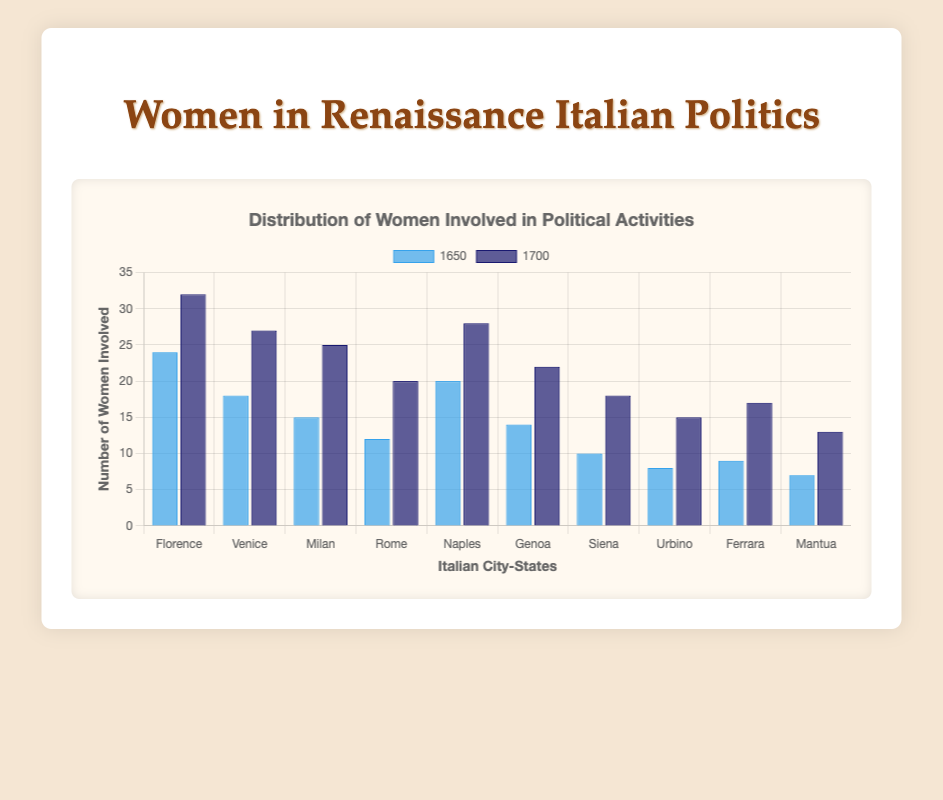Which city-state had the most significant increase in the number of women involved in political activities from 1650 to 1700? The increase in each city-state is calculated by subtracting the number of women involved in 1650 from the number involved in 1700. Florence had an increase of 8 (32 - 24), Venice had an increase of 9 (27 - 18), Milan had an increase of 10 (25 - 15), Rome had an increase of 8 (20 - 12), Naples had an increase of 8 (28 - 20), Genoa had an increase of 8 (22 - 14), Siena had an increase of 8 (18 - 10), Urbino had an increase of 7 (15 - 8), Ferrara had an increase of 8 (17 - 9), and Mantua had an increase of 6 (13 - 7). As a result, Milan had the most significant increase.
Answer: Milan Which city-state had the lowest number of women involved in political activities in 1650? Looking at the bar representing 1650, the lowest bar corresponds to Mantua, which had 7 women involved.
Answer: Mantua How many total women were involved in political activities across all city-states in 1700? Add the number of women involved in each city-state in 1700: 32 (Florence) + 27 (Venice) + 25 (Milan) + 20 (Rome) + 28 (Naples) + 22 (Genoa) + 18 (Siena) + 15 (Urbino) + 17 (Ferrara) + 13 (Mantua). The total is 217.
Answer: 217 Which city-state showed the smallest relative growth in the number of women involved from 1650 to 1700? Calculate the relative growth by dividing the increase by the number of women involved in 1650. Florence's growth is 8/24, Venice's is 9/18, Milan's is 10/15, Rome's is 8/12, Naples' is 8/20, Genoa's is 8/14, Siena's is 8/10, Urbino’s is 7/8, Ferrara's is 8/9, and Mantua's is 6/7. Urbino has the smallest relative growth.
Answer: Urbino Which city-states had equal numbers of women involved in political activities in both 1650 and 1700? By comparing the bars, no city-states have equal numbers of women involved in both 1650 and 1700.
Answer: None What is the average number of women involved in political activities across all city-states in 1650? Add the number of women involved in each city-state in 1650 and divide by the number of city-states: (24 + 18 + 15 + 12 + 20 + 14 + 10 + 8 + 9 + 7) / 10. This equals 137 / 10, so the average is 13.7.
Answer: 13.7 Which city-state had the highest number of women involved in political activities in 1700? Comparing the heights of the bars for the year 1700, Florence had the highest number with 32 women involved.
Answer: Florence What is the total increase in the number of women involved in political activities from 1650 to 1700 across all city-states? Calculate the increase for each city-state and sum them up: (32-24) + (27-18) + (25-15) + (20-12) + (28-20) + (22-14) + (18-10) + (15-8) + (17-9) + (13-7). This equals 80.
Answer: 80 How many more women were involved in political activities in Naples in 1700 compared to 1650? In Naples, 28 women were involved in 1700 compared to 20 in 1650. The difference is 28 - 20, resulting in an increase of 8 women.
Answer: 8 